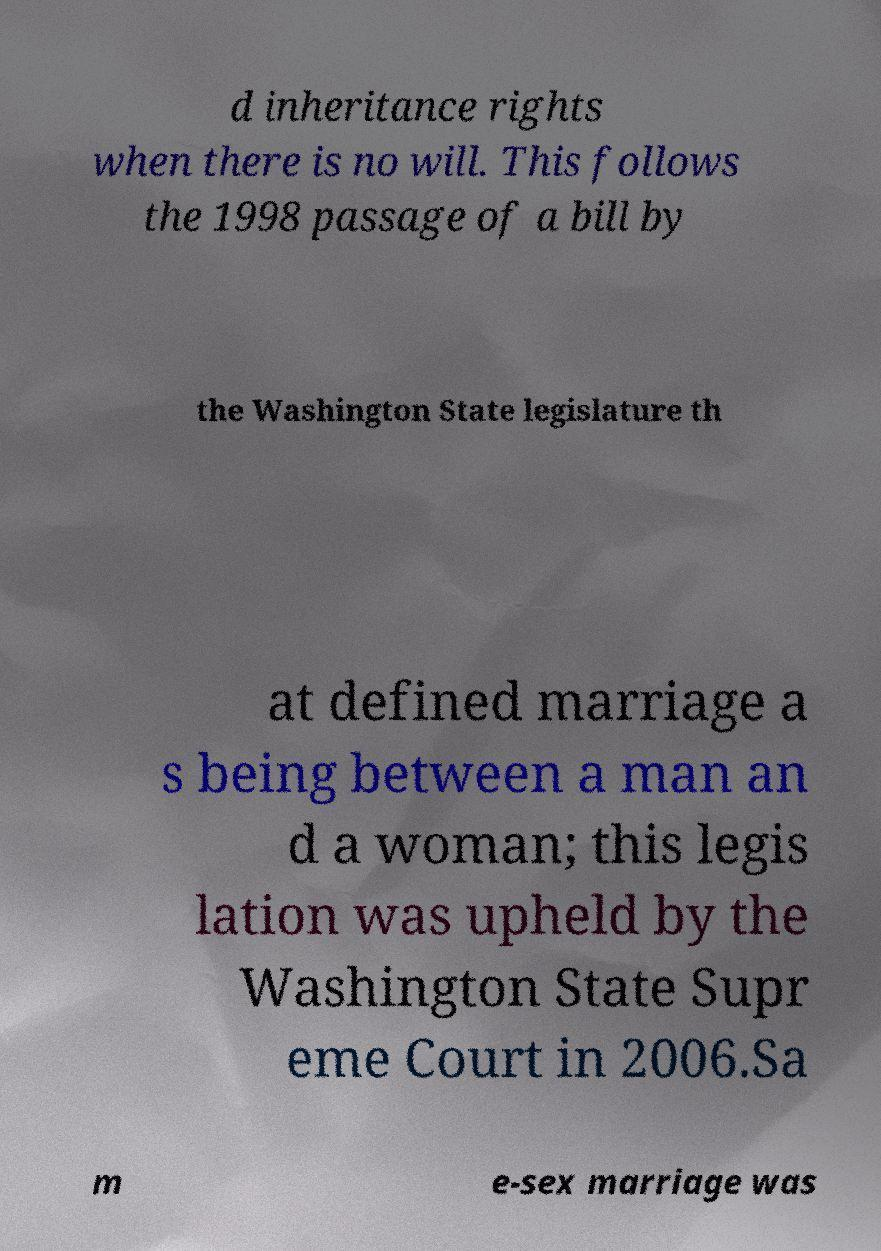Could you extract and type out the text from this image? d inheritance rights when there is no will. This follows the 1998 passage of a bill by the Washington State legislature th at defined marriage a s being between a man an d a woman; this legis lation was upheld by the Washington State Supr eme Court in 2006.Sa m e-sex marriage was 